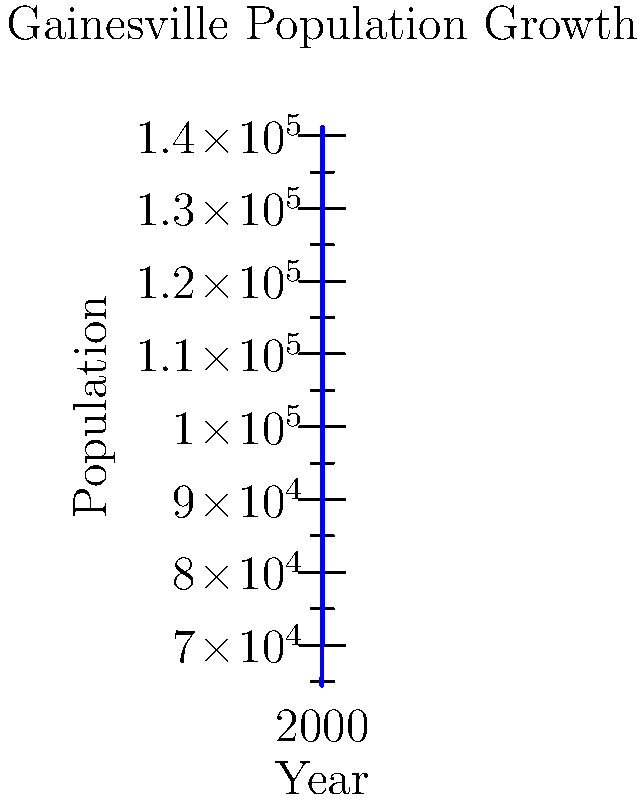Based on the line graph showing Gainesville's population growth from 1970 to 2020, in which decade did the city experience the most significant increase in population? To determine the decade with the most significant population increase, we need to calculate the population change for each decade and compare:

1. 1970-1980: 81,371 - 64,510 = 16,861
2. 1980-1990: 84,770 - 81,371 = 3,399
3. 1990-2000: 95,447 - 84,770 = 10,677
4. 2000-2010: 124,354 - 95,447 = 28,907
5. 2010-2020: 141,085 - 124,354 = 16,731

The largest increase occurred between 2000 and 2010, with a population growth of 28,907.
Answer: 2000-2010 